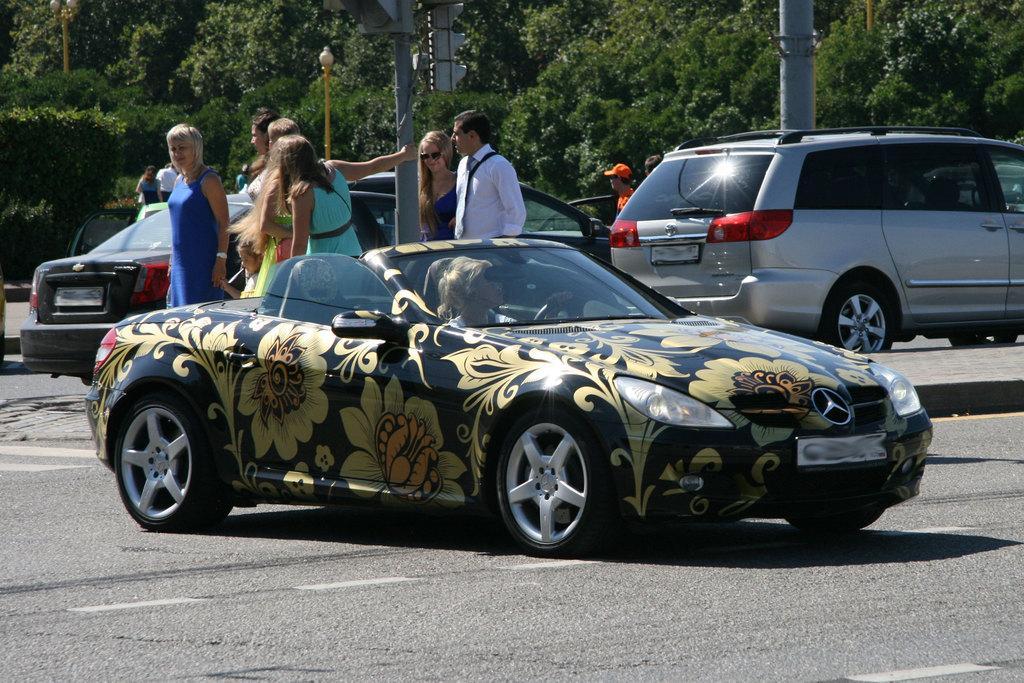How would you summarize this image in a sentence or two? In the picture I can see a black color car on which I can see flowers in which a person is sitting is moving on the road and we can see a few people walking on the sidewalk, I can see a few more vehicles moving on the road and I can see poles and trees in the background. 